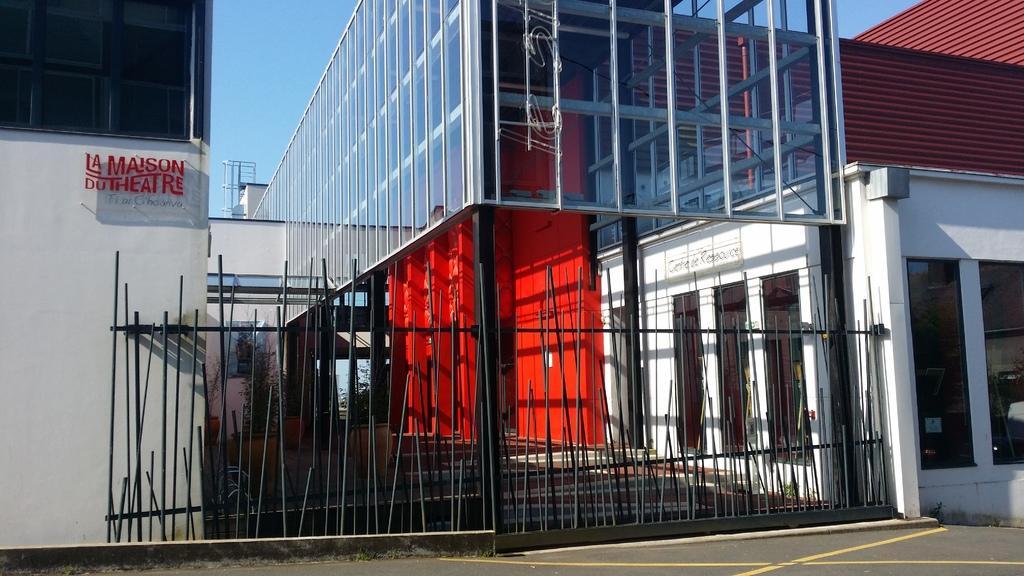Can you describe this image briefly? Front we can see a gate. Background there is a building with glass windows. Here we can see plants. Sky is in blue color. 